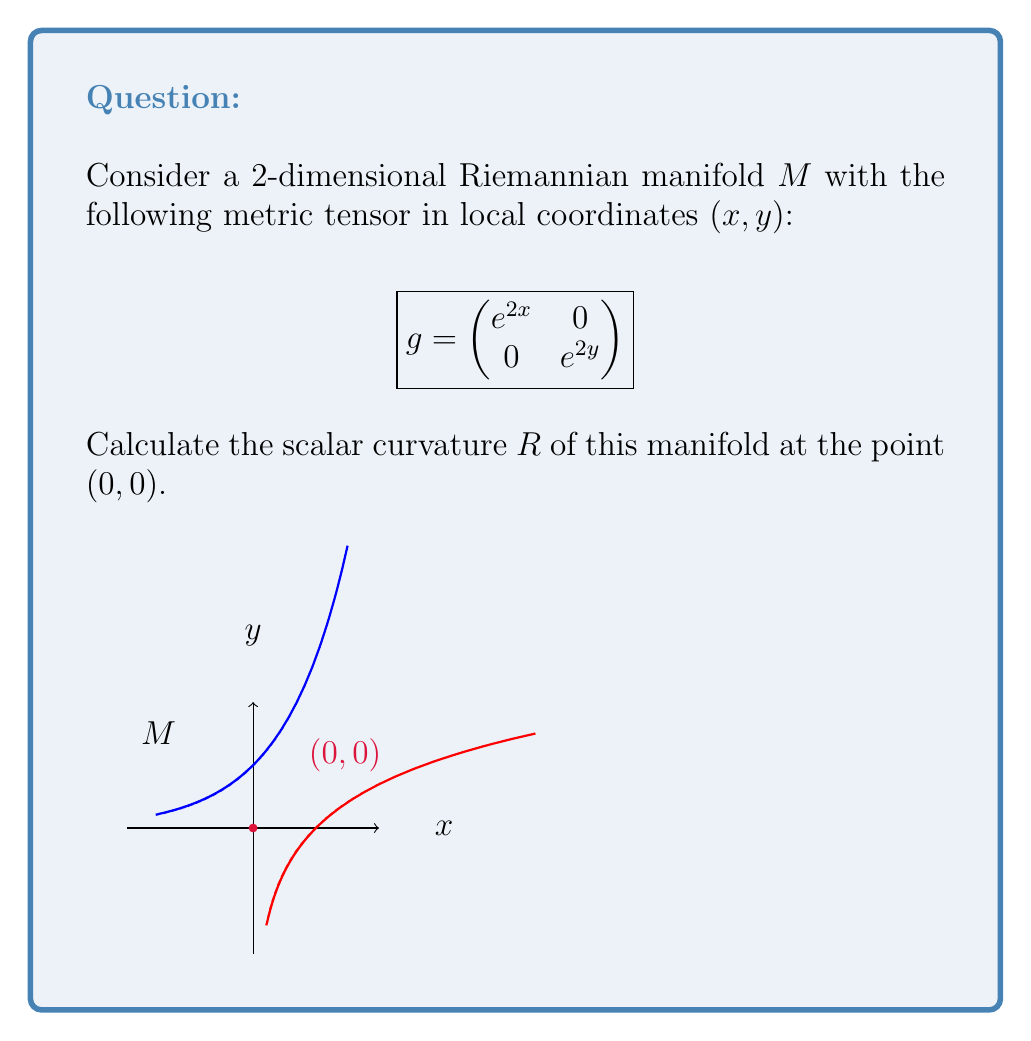Help me with this question. To determine the scalar curvature, we need to follow these steps:

1) First, we need to calculate the Christoffel symbols $\Gamma^k_{ij}$:
   $$\Gamma^k_{ij} = \frac{1}{2}g^{kl}(\partial_i g_{jl} + \partial_j g_{il} - \partial_l g_{ij})$$

2) The non-zero Christoffel symbols are:
   $$\Gamma^1_{11} = 1, \quad \Gamma^2_{22} = 1$$

3) Next, we calculate the Riemann curvature tensor $R^i_{jkl}$:
   $$R^i_{jkl} = \partial_k \Gamma^i_{jl} - \partial_l \Gamma^i_{jk} + \Gamma^i_{km}\Gamma^m_{jl} - \Gamma^i_{lm}\Gamma^m_{jk}$$

4) The non-zero components of the Riemann tensor are:
   $$R^1_{212} = -e^{-2x}, \quad R^2_{121} = -e^{-2y}$$

5) We then compute the Ricci tensor $R_{ij}$:
   $$R_{ij} = R^k_{ikj}$$

6) The non-zero components of the Ricci tensor are:
   $$R_{11} = -e^{2x}, \quad R_{22} = -e^{2y}$$

7) Finally, we calculate the scalar curvature $R$:
   $$R = g^{ij}R_{ij} = e^{-2x}(-e^{2x}) + e^{-2y}(-e^{2y}) = -2$$

8) At the point $(0, 0)$, the scalar curvature is simply $-2$.
Answer: $R = -2$ 